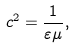Convert formula to latex. <formula><loc_0><loc_0><loc_500><loc_500>c ^ { 2 } = \frac { 1 } { \varepsilon \mu } ,</formula> 